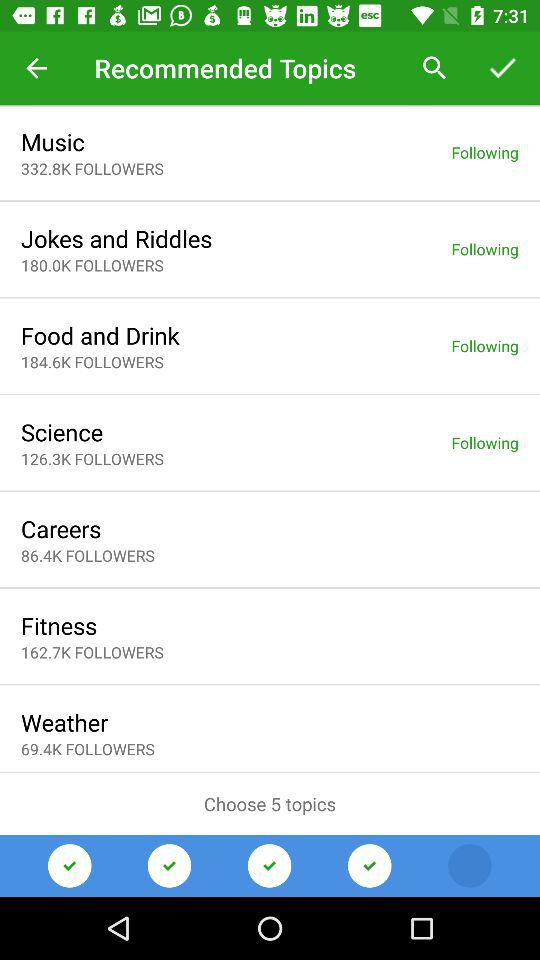How many followers does "Fitness" have? "Fitness" has 162.7K followers. 